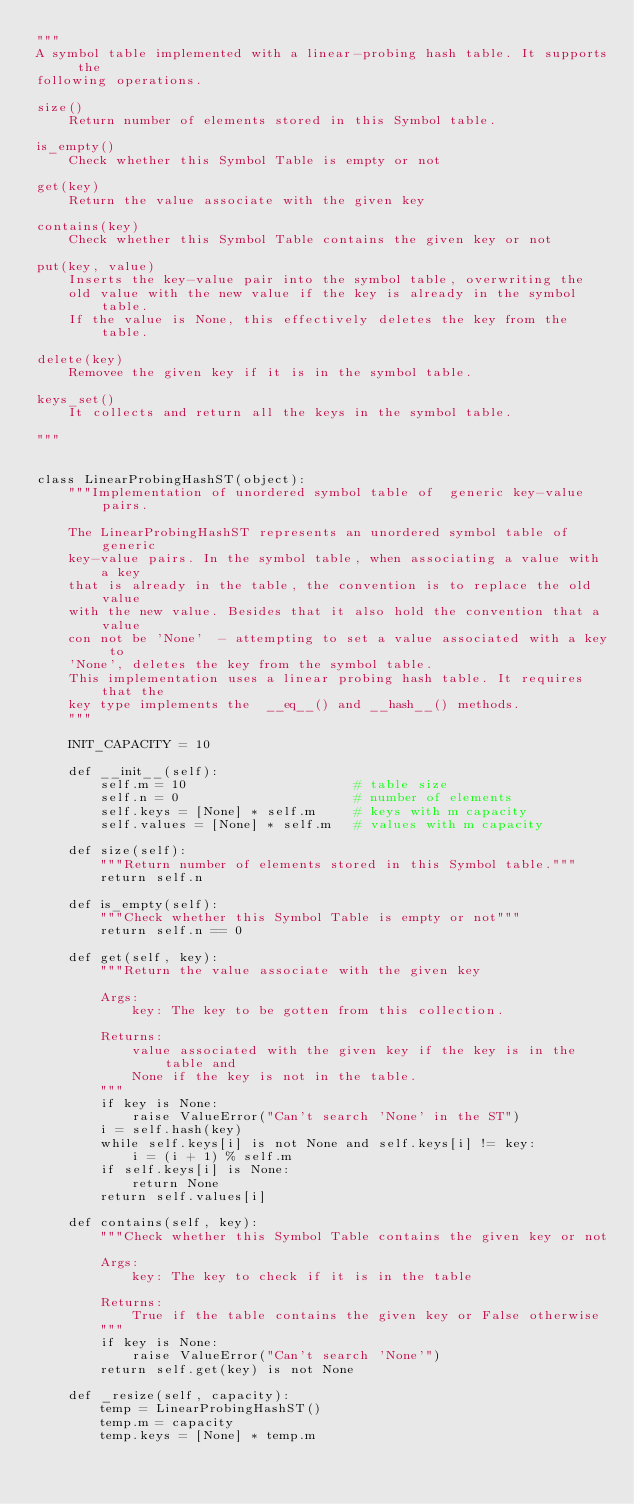Convert code to text. <code><loc_0><loc_0><loc_500><loc_500><_Python_>"""
A symbol table implemented with a linear-probing hash table. It supports the 
following operations. 

size()
    Return number of elements stored in this Symbol table.

is_empty()
    Check whether this Symbol Table is empty or not

get(key)
    Return the value associate with the given key

contains(key)
    Check whether this Symbol Table contains the given key or not

put(key, value)
    Inserts the key-value pair into the symbol table, overwriting the
    old value with the new value if the key is already in the symbol table.
    If the value is None, this effectively deletes the key from the table.

delete(key)
    Removee the given key if it is in the symbol table.

keys_set()
    It collects and return all the keys in the symbol table.

"""


class LinearProbingHashST(object):
    """Implementation of unordered symbol table of  generic key-value pairs.

    The LinearProbingHashST represents an unordered symbol table of  generic
    key-value pairs. In the symbol table, when associating a value with a key
    that is already in the table, the convention is to replace the old value
    with the new value. Besides that it also hold the convention that a value
    con not be 'None'  - attempting to set a value associated with a key to
    'None', deletes the key from the symbol table.
    This implementation uses a linear probing hash table. It requires that the
    key type implements the  __eq__() and __hash__() methods.
    """

    INIT_CAPACITY = 10

    def __init__(self):
        self.m = 10                     # table size
        self.n = 0                      # number of elements
        self.keys = [None] * self.m     # keys with m capacity
        self.values = [None] * self.m   # values with m capacity

    def size(self):
        """Return number of elements stored in this Symbol table."""
        return self.n

    def is_empty(self):
        """Check whether this Symbol Table is empty or not"""
        return self.n == 0

    def get(self, key):
        """Return the value associate with the given key

        Args:
            key: The key to be gotten from this collection.
        
        Returns:
            value associated with the given key if the key is in the table and
            None if the key is not in the table.
        """
        if key is None:
            raise ValueError("Can't search 'None' in the ST")
        i = self.hash(key)
        while self.keys[i] is not None and self.keys[i] != key:
            i = (i + 1) % self.m
        if self.keys[i] is None:
            return None
        return self.values[i]

    def contains(self, key):
        """Check whether this Symbol Table contains the given key or not

        Args:
            key: The key to check if it is in the table
        
        Returns:
            True if the table contains the given key or False otherwise
        """
        if key is None:
            raise ValueError("Can't search 'None'")
        return self.get(key) is not None

    def _resize(self, capacity):
        temp = LinearProbingHashST()
        temp.m = capacity
        temp.keys = [None] * temp.m</code> 